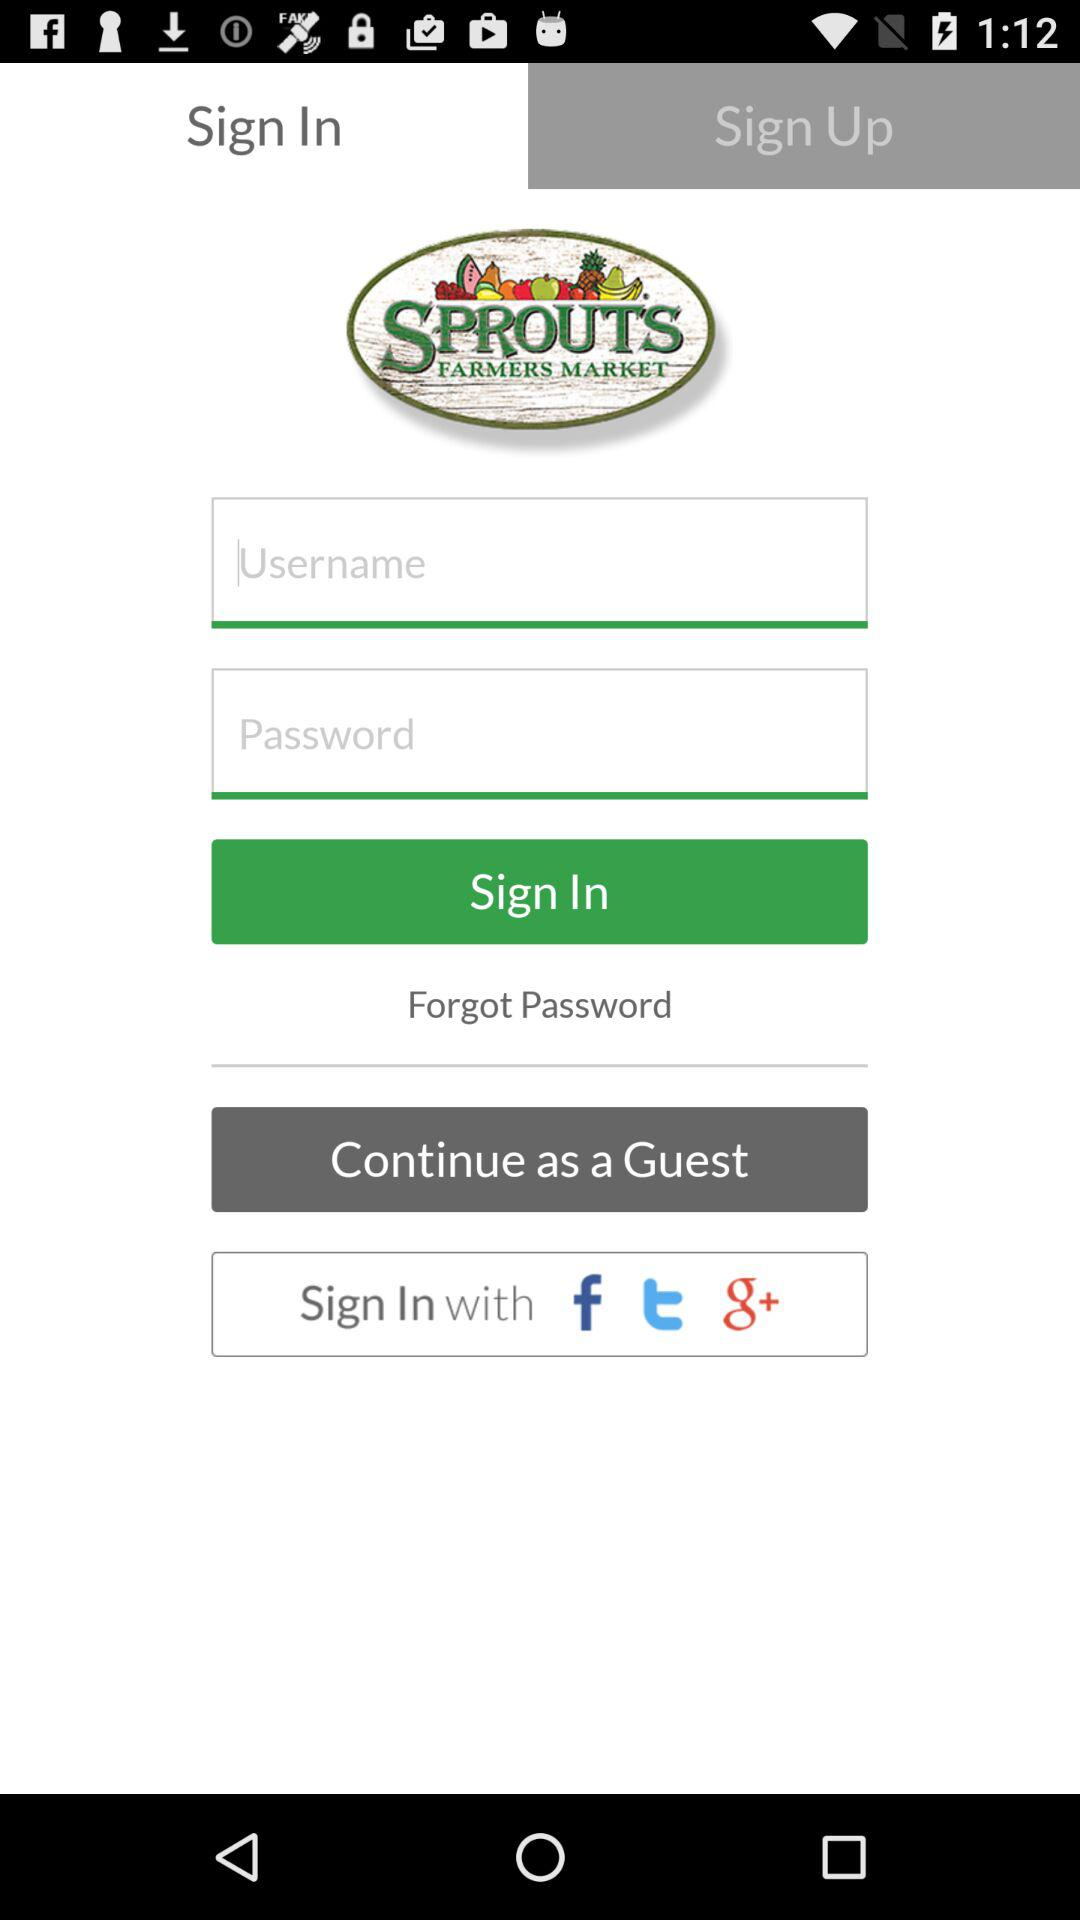What accounts can I use to sign in? You can use "Guest", "Facebook", "Twitter" and "Google Plus" accounts to sign in. 